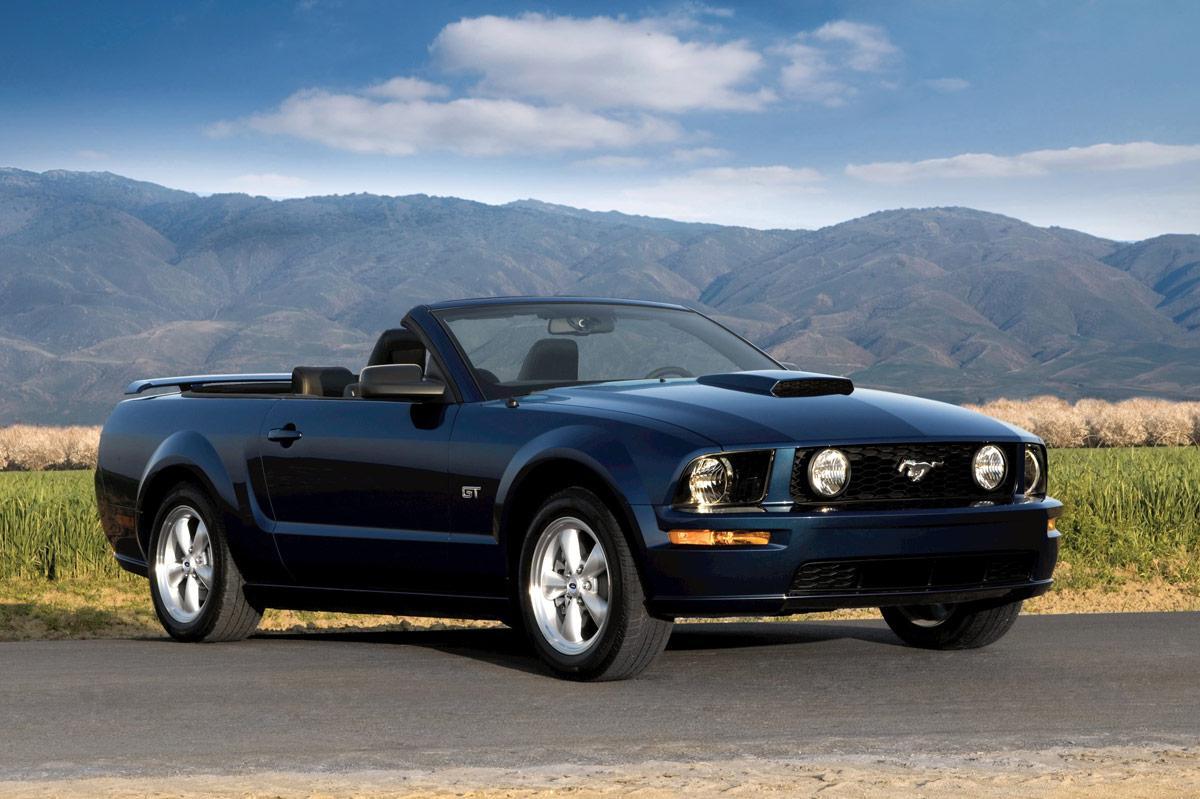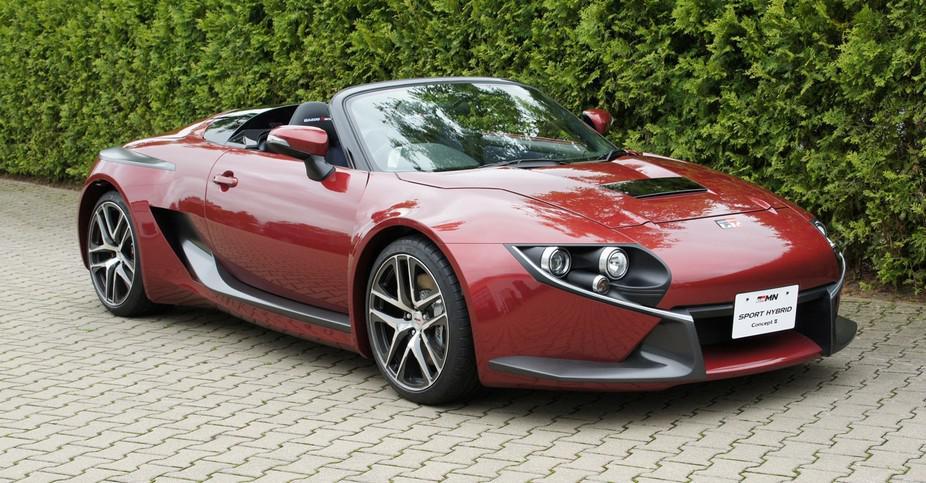The first image is the image on the left, the second image is the image on the right. Given the left and right images, does the statement "An image shows one red convertible with top down, turned at a leftward-facing angle." hold true? Answer yes or no. No. The first image is the image on the left, the second image is the image on the right. For the images shown, is this caption "A red sportscar and a light colored sportscar are both convertibles with chrome wheels, black interiors, and logo at center front." true? Answer yes or no. No. 